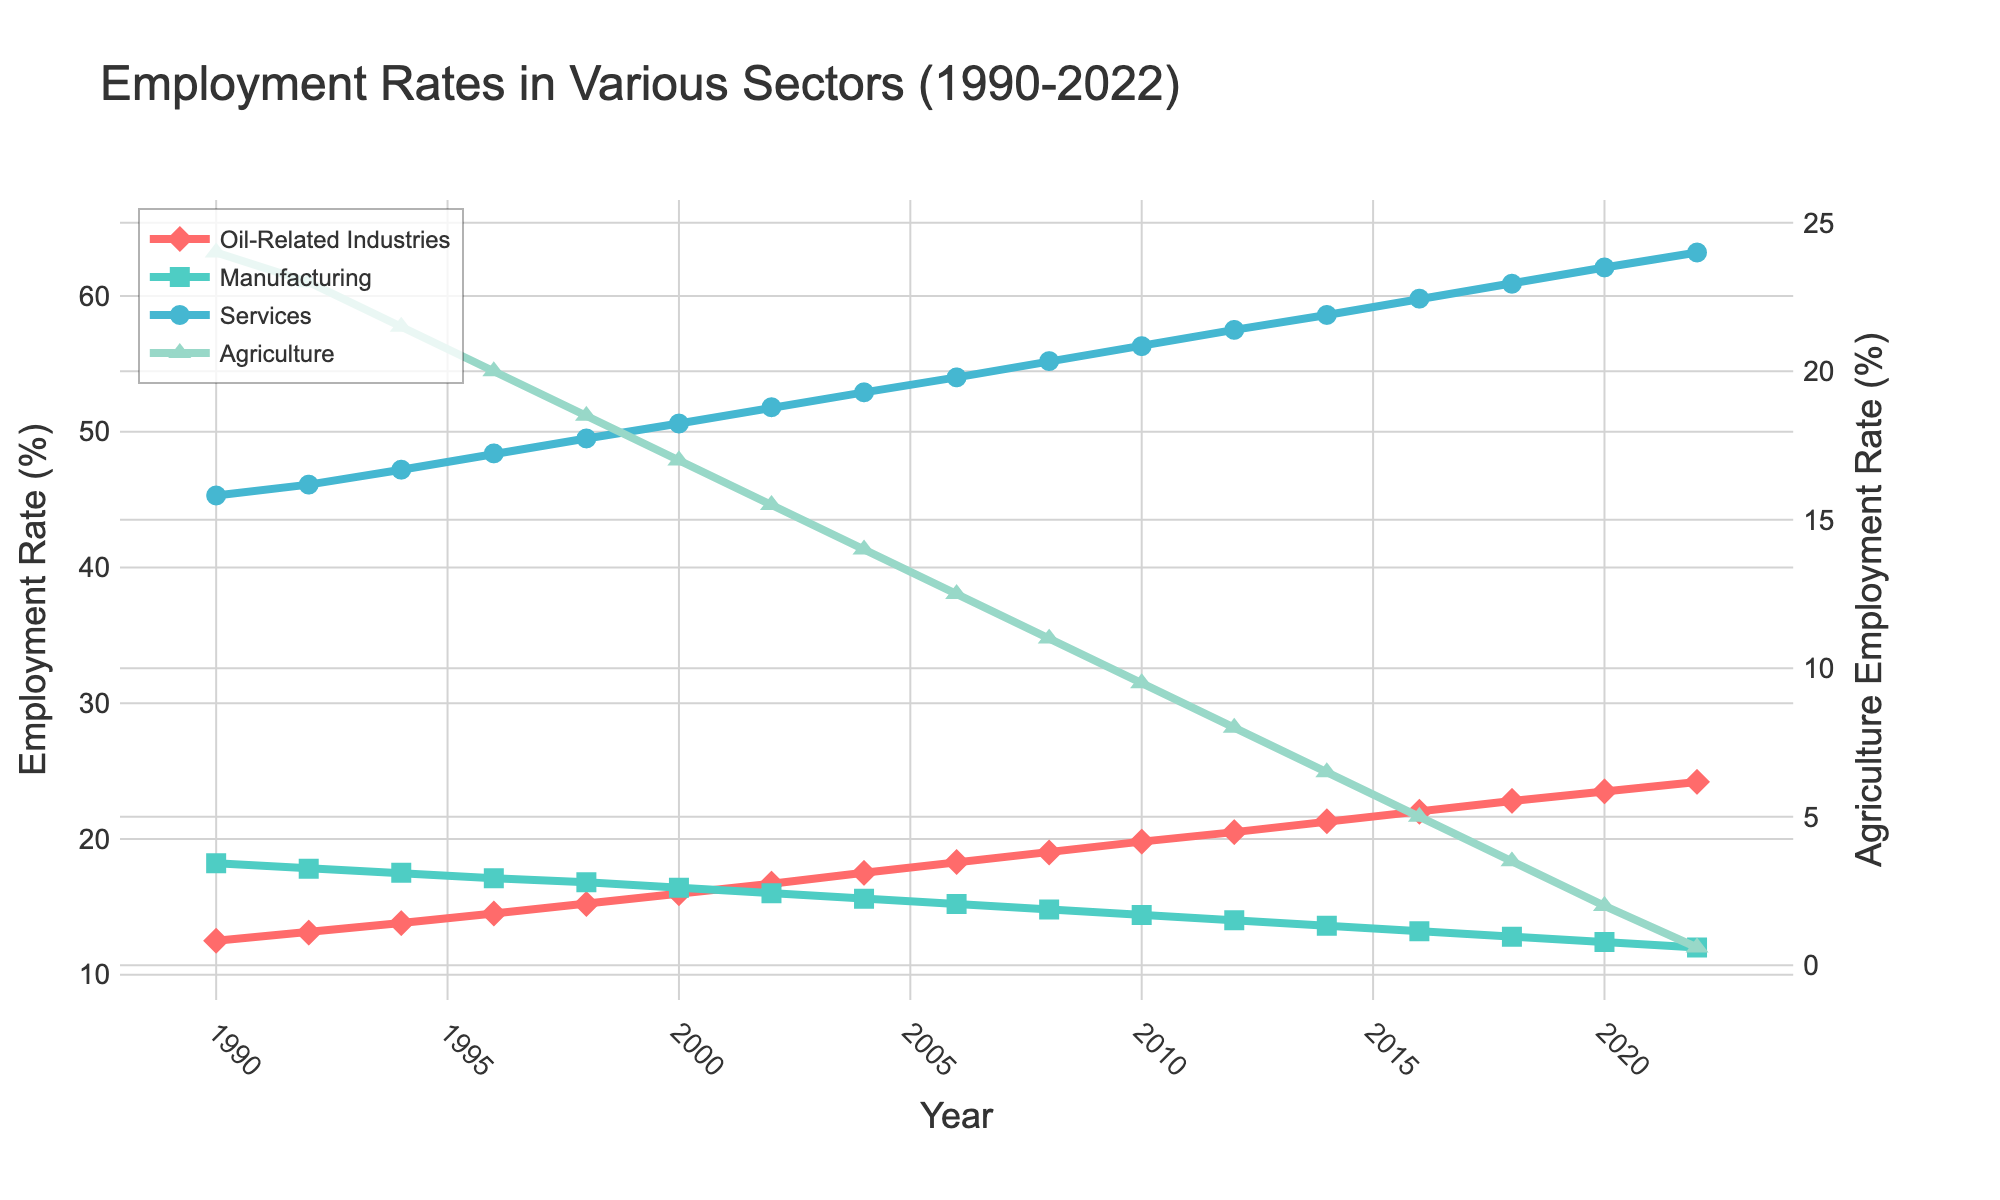What trend can be observed in employment rates in oil-related industries from 1990 to 2022? The employment rate in oil-related industries has shown a consistent increase from 12.5% in 1990 to 24.2% in 2022.
Answer: An increasing trend How did the employment rate in the agriculture sector change from 1990 to 2022? The employment rate in the agriculture sector has consistently decreased from 24.0% in 1990 to 0.6% in 2022.
Answer: A decreasing trend Compare the employment rates in services in 1990 and 2022. In 1990, the employment rate in services was 45.3%, and in 2022, it rose to 63.2%.
Answer: Increased Which sector saw the biggest change in employment rate from 1990 to 2022? To find the biggest change, calculate the differences: 
Oil-Related Industries: 24.2% - 12.5% = 11.7%
Manufacturing: 12.0% - 18.2% = -6.2%
Services: 63.2% - 45.3% = 17.9%
Agriculture: 0.6% - 24.0% = -23.4%
Agriculture had the biggest decrease by 23.4%.
Answer: Agriculture In what year did the employment rate in oil-related industries first surpass 20%? The employment rate in oil-related industries first surpassed 20% in 2012 at 20.5%.
Answer: 2012 What is the average employment rate in the services sector over the entire period? Sum the employment rates from 1990 to 2022 and divide by the number of years (33 years):
(45.3 + 46.1 + 47.2 + 48.4 + 49.5 + 50.6 + 51.8 + 52.9 + 54.0 + 55.2 + 56.3 + 57.5 + 58.6 + 59.8 + 60.9 + 62.1 + 63.2) / 33 ≈ 53.1
Answer: 53.1% Between which consecutive years did the manufacturing sector experience the largest drop in employment rates? Check the differences between consecutive years:
1990-1992: 18.2 - 17.8 = 0.4
1992-1994: 17.8 - 17.5 = 0.3
1994-1996: 17.5 - 17.1 = 0.4
1996-1998: 17.1 - 16.8 = 0.3
1998-2000: 16.8 - 16.4 = 0.4
2000-2002: 16.4 - 16.0 = 0.4
2002-2004: 16.0 - 15.6 = 0.4
2004-2006: 15.6 - 15.2 = 0.4
2006-2008: 15.2 - 14.8 = 0.4
2008-2010: 14.8 - 14.4 = 0.4
2010-2012: 14.4 - 14.0 = 0.4
2012-2014: 14.0 - 13.6 = 0.4
2014-2016: 13.6 - 13.2 = 0.4
2016-2018: 13.2 - 12.8 = 0.4
2018-2020: 12.8 - 12.4 = 0.4
2020-2022: 12.4 - 12.0 = 0.4
Large drops all appear to be 0.4 but closer visual inspection shows these consistent drops indicate gradual decrease rather than a sudden drop.
Answer: Gradual decrease Which sector dominates the employment rate in 2022? In 2022, the employment rate in services is the highest at 63.2%, dominating other sectors.
Answer: Services By how much did the employment rate in oil-related industries increase between 2000 and 2008? The employment rate in oil-related industries in 2000 was 16.0% and in 2008 it was 19.0%, so the increase is 19.0% - 16.0% = 3.0%.
Answer: 3.0% What is the employment rate difference between manufacturing and agriculture in 2022? In 2022, the employment rate in manufacturing is 12.0% and in agriculture it is 0.6%, so the difference is 12.0% - 0.6% = 11.4%.
Answer: 11.4% 